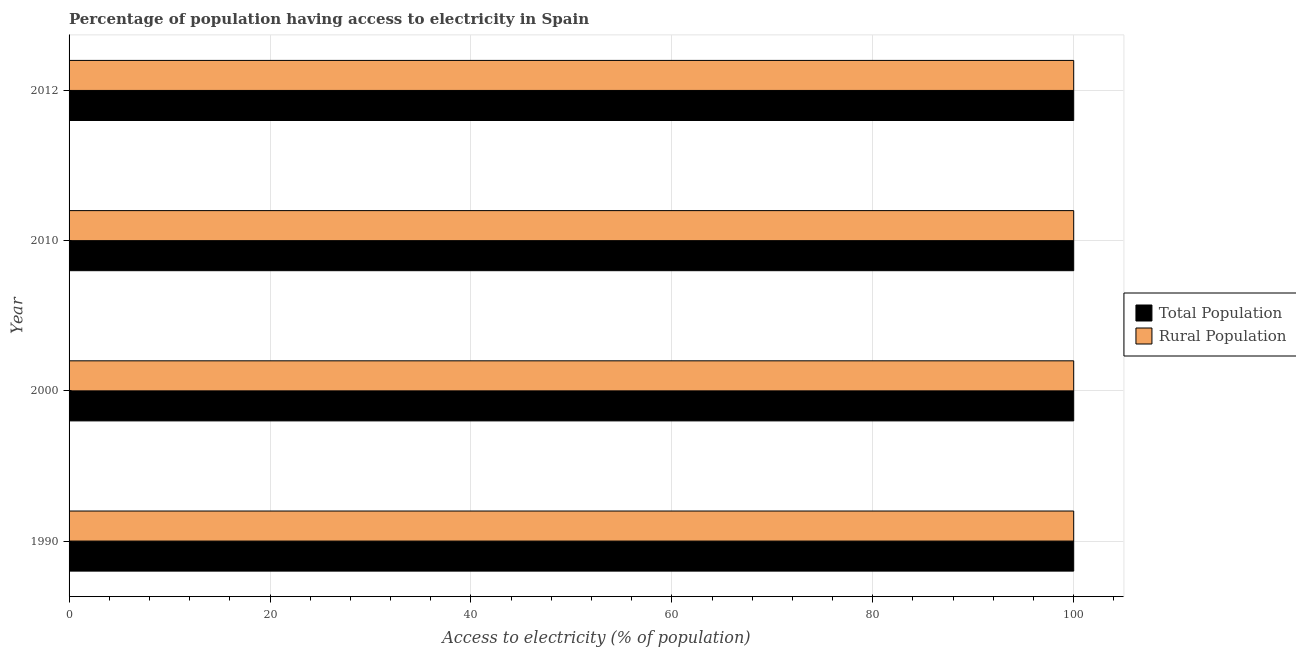How many different coloured bars are there?
Your response must be concise. 2. How many groups of bars are there?
Keep it short and to the point. 4. Are the number of bars per tick equal to the number of legend labels?
Give a very brief answer. Yes. Are the number of bars on each tick of the Y-axis equal?
Provide a succinct answer. Yes. How many bars are there on the 3rd tick from the bottom?
Provide a short and direct response. 2. What is the percentage of rural population having access to electricity in 1990?
Ensure brevity in your answer.  100. Across all years, what is the maximum percentage of rural population having access to electricity?
Your response must be concise. 100. Across all years, what is the minimum percentage of rural population having access to electricity?
Your response must be concise. 100. In which year was the percentage of rural population having access to electricity minimum?
Offer a very short reply. 1990. What is the total percentage of rural population having access to electricity in the graph?
Keep it short and to the point. 400. What is the difference between the percentage of rural population having access to electricity in 2000 and that in 2012?
Your answer should be very brief. 0. What is the difference between the percentage of rural population having access to electricity in 2012 and the percentage of population having access to electricity in 2010?
Your answer should be very brief. 0. What is the average percentage of rural population having access to electricity per year?
Offer a very short reply. 100. What is the ratio of the percentage of population having access to electricity in 2000 to that in 2012?
Provide a short and direct response. 1. Is the percentage of population having access to electricity in 2000 less than that in 2012?
Offer a very short reply. No. Is the difference between the percentage of rural population having access to electricity in 2000 and 2012 greater than the difference between the percentage of population having access to electricity in 2000 and 2012?
Give a very brief answer. No. What is the difference between the highest and the second highest percentage of population having access to electricity?
Ensure brevity in your answer.  0. In how many years, is the percentage of rural population having access to electricity greater than the average percentage of rural population having access to electricity taken over all years?
Keep it short and to the point. 0. What does the 2nd bar from the top in 2000 represents?
Provide a succinct answer. Total Population. What does the 1st bar from the bottom in 1990 represents?
Provide a short and direct response. Total Population. How many bars are there?
Your answer should be compact. 8. Are all the bars in the graph horizontal?
Offer a terse response. Yes. How many years are there in the graph?
Your answer should be compact. 4. What is the difference between two consecutive major ticks on the X-axis?
Your answer should be very brief. 20. Does the graph contain grids?
Offer a terse response. Yes. Where does the legend appear in the graph?
Ensure brevity in your answer.  Center right. How many legend labels are there?
Your answer should be compact. 2. How are the legend labels stacked?
Your response must be concise. Vertical. What is the title of the graph?
Make the answer very short. Percentage of population having access to electricity in Spain. Does "State government" appear as one of the legend labels in the graph?
Offer a terse response. No. What is the label or title of the X-axis?
Provide a succinct answer. Access to electricity (% of population). What is the label or title of the Y-axis?
Make the answer very short. Year. What is the Access to electricity (% of population) of Total Population in 1990?
Make the answer very short. 100. What is the Access to electricity (% of population) in Rural Population in 2000?
Provide a succinct answer. 100. What is the Access to electricity (% of population) of Rural Population in 2010?
Your answer should be very brief. 100. What is the Access to electricity (% of population) in Total Population in 2012?
Make the answer very short. 100. Across all years, what is the maximum Access to electricity (% of population) in Rural Population?
Offer a terse response. 100. Across all years, what is the minimum Access to electricity (% of population) of Total Population?
Provide a short and direct response. 100. Across all years, what is the minimum Access to electricity (% of population) in Rural Population?
Give a very brief answer. 100. What is the total Access to electricity (% of population) in Total Population in the graph?
Your answer should be compact. 400. What is the difference between the Access to electricity (% of population) in Total Population in 1990 and that in 2000?
Give a very brief answer. 0. What is the difference between the Access to electricity (% of population) in Rural Population in 1990 and that in 2012?
Your answer should be compact. 0. What is the difference between the Access to electricity (% of population) of Total Population in 2000 and that in 2012?
Provide a succinct answer. 0. What is the difference between the Access to electricity (% of population) of Rural Population in 2000 and that in 2012?
Your answer should be very brief. 0. What is the difference between the Access to electricity (% of population) of Total Population in 2010 and that in 2012?
Offer a very short reply. 0. What is the difference between the Access to electricity (% of population) of Total Population in 1990 and the Access to electricity (% of population) of Rural Population in 2010?
Provide a short and direct response. 0. What is the difference between the Access to electricity (% of population) of Total Population in 2000 and the Access to electricity (% of population) of Rural Population in 2010?
Offer a very short reply. 0. What is the difference between the Access to electricity (% of population) in Total Population in 2000 and the Access to electricity (% of population) in Rural Population in 2012?
Provide a short and direct response. 0. What is the difference between the Access to electricity (% of population) in Total Population in 2010 and the Access to electricity (% of population) in Rural Population in 2012?
Ensure brevity in your answer.  0. What is the ratio of the Access to electricity (% of population) of Total Population in 1990 to that in 2000?
Keep it short and to the point. 1. What is the ratio of the Access to electricity (% of population) in Rural Population in 1990 to that in 2000?
Provide a short and direct response. 1. What is the ratio of the Access to electricity (% of population) in Total Population in 1990 to that in 2010?
Ensure brevity in your answer.  1. What is the ratio of the Access to electricity (% of population) of Rural Population in 1990 to that in 2010?
Make the answer very short. 1. What is the ratio of the Access to electricity (% of population) of Total Population in 1990 to that in 2012?
Provide a short and direct response. 1. What is the ratio of the Access to electricity (% of population) of Rural Population in 1990 to that in 2012?
Your response must be concise. 1. What is the ratio of the Access to electricity (% of population) of Rural Population in 2000 to that in 2010?
Keep it short and to the point. 1. What is the difference between the highest and the lowest Access to electricity (% of population) in Rural Population?
Offer a terse response. 0. 